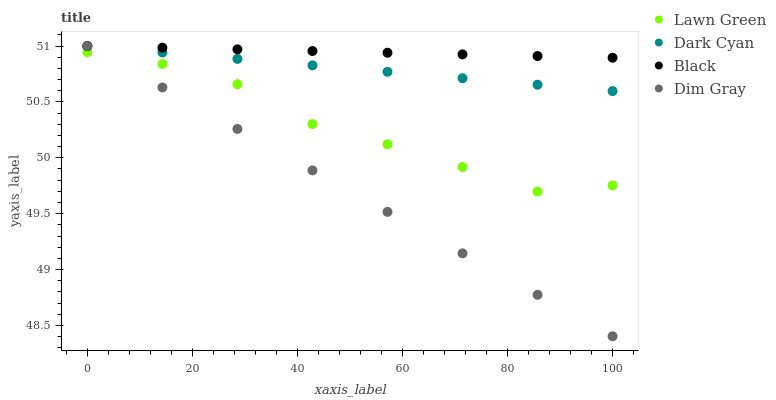Does Dim Gray have the minimum area under the curve?
Answer yes or no. Yes. Does Black have the maximum area under the curve?
Answer yes or no. Yes. Does Lawn Green have the minimum area under the curve?
Answer yes or no. No. Does Lawn Green have the maximum area under the curve?
Answer yes or no. No. Is Black the smoothest?
Answer yes or no. Yes. Is Lawn Green the roughest?
Answer yes or no. Yes. Is Dim Gray the smoothest?
Answer yes or no. No. Is Dim Gray the roughest?
Answer yes or no. No. Does Dim Gray have the lowest value?
Answer yes or no. Yes. Does Lawn Green have the lowest value?
Answer yes or no. No. Does Black have the highest value?
Answer yes or no. Yes. Does Lawn Green have the highest value?
Answer yes or no. No. Is Lawn Green less than Dark Cyan?
Answer yes or no. Yes. Is Dark Cyan greater than Lawn Green?
Answer yes or no. Yes. Does Lawn Green intersect Dim Gray?
Answer yes or no. Yes. Is Lawn Green less than Dim Gray?
Answer yes or no. No. Is Lawn Green greater than Dim Gray?
Answer yes or no. No. Does Lawn Green intersect Dark Cyan?
Answer yes or no. No. 